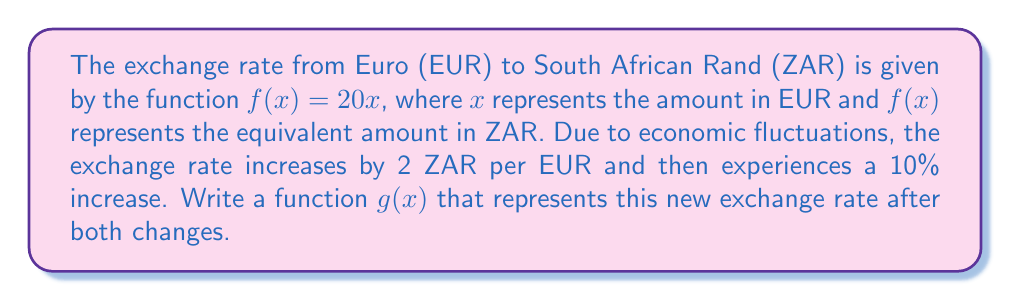Solve this math problem. Let's approach this step-by-step:

1) The original function is $f(x) = 20x$.

2) First, the exchange rate increases by 2 ZAR per EUR. This is a vertical shift upward by 2 units. We can represent this as:

   $f_1(x) = 20x + 2$

3) Next, there's a 10% increase. This means we need to multiply the entire function by 1.10:

   $g(x) = 1.10(f_1(x)) = 1.10(20x + 2)$

4) Expanding this:

   $g(x) = 22x + 2.2$

5) Therefore, the new function $g(x)$ represents the exchange rate after both changes.
Answer: $g(x) = 22x + 2.2$ 